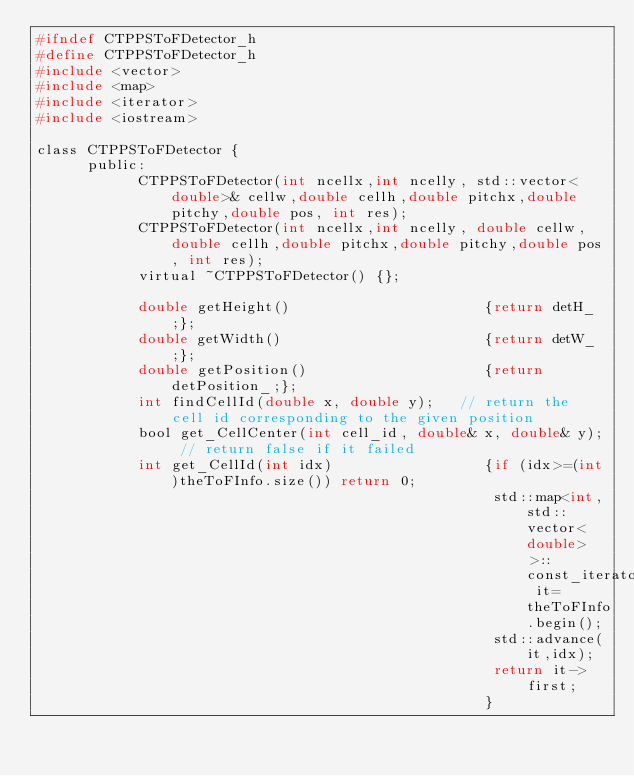Convert code to text. <code><loc_0><loc_0><loc_500><loc_500><_C_>#ifndef CTPPSToFDetector_h
#define CTPPSToFDetector_h
#include <vector>
#include <map>
#include <iterator>
#include <iostream>

class CTPPSToFDetector {
      public:
            CTPPSToFDetector(int ncellx,int ncelly, std::vector<double>& cellw,double cellh,double pitchx,double pitchy,double pos, int res);
            CTPPSToFDetector(int ncellx,int ncelly, double cellw,double cellh,double pitchx,double pitchy,double pos, int res);
            virtual ~CTPPSToFDetector() {};

            double getHeight()                       {return detH_;};
            double getWidth()                        {return detW_;};
            double getPosition()                     {return detPosition_;};
            int findCellId(double x, double y);   // return the cell id corresponding to the given position
            bool get_CellCenter(int cell_id, double& x, double& y); // return false if it failed
            int get_CellId(int idx)                  {if (idx>=(int)theToFInfo.size()) return 0;
                                                      std::map<int,std::vector<double> >::const_iterator it=theToFInfo.begin();
                                                      std::advance(it,idx);
                                                      return it->first;
                                                     }</code> 